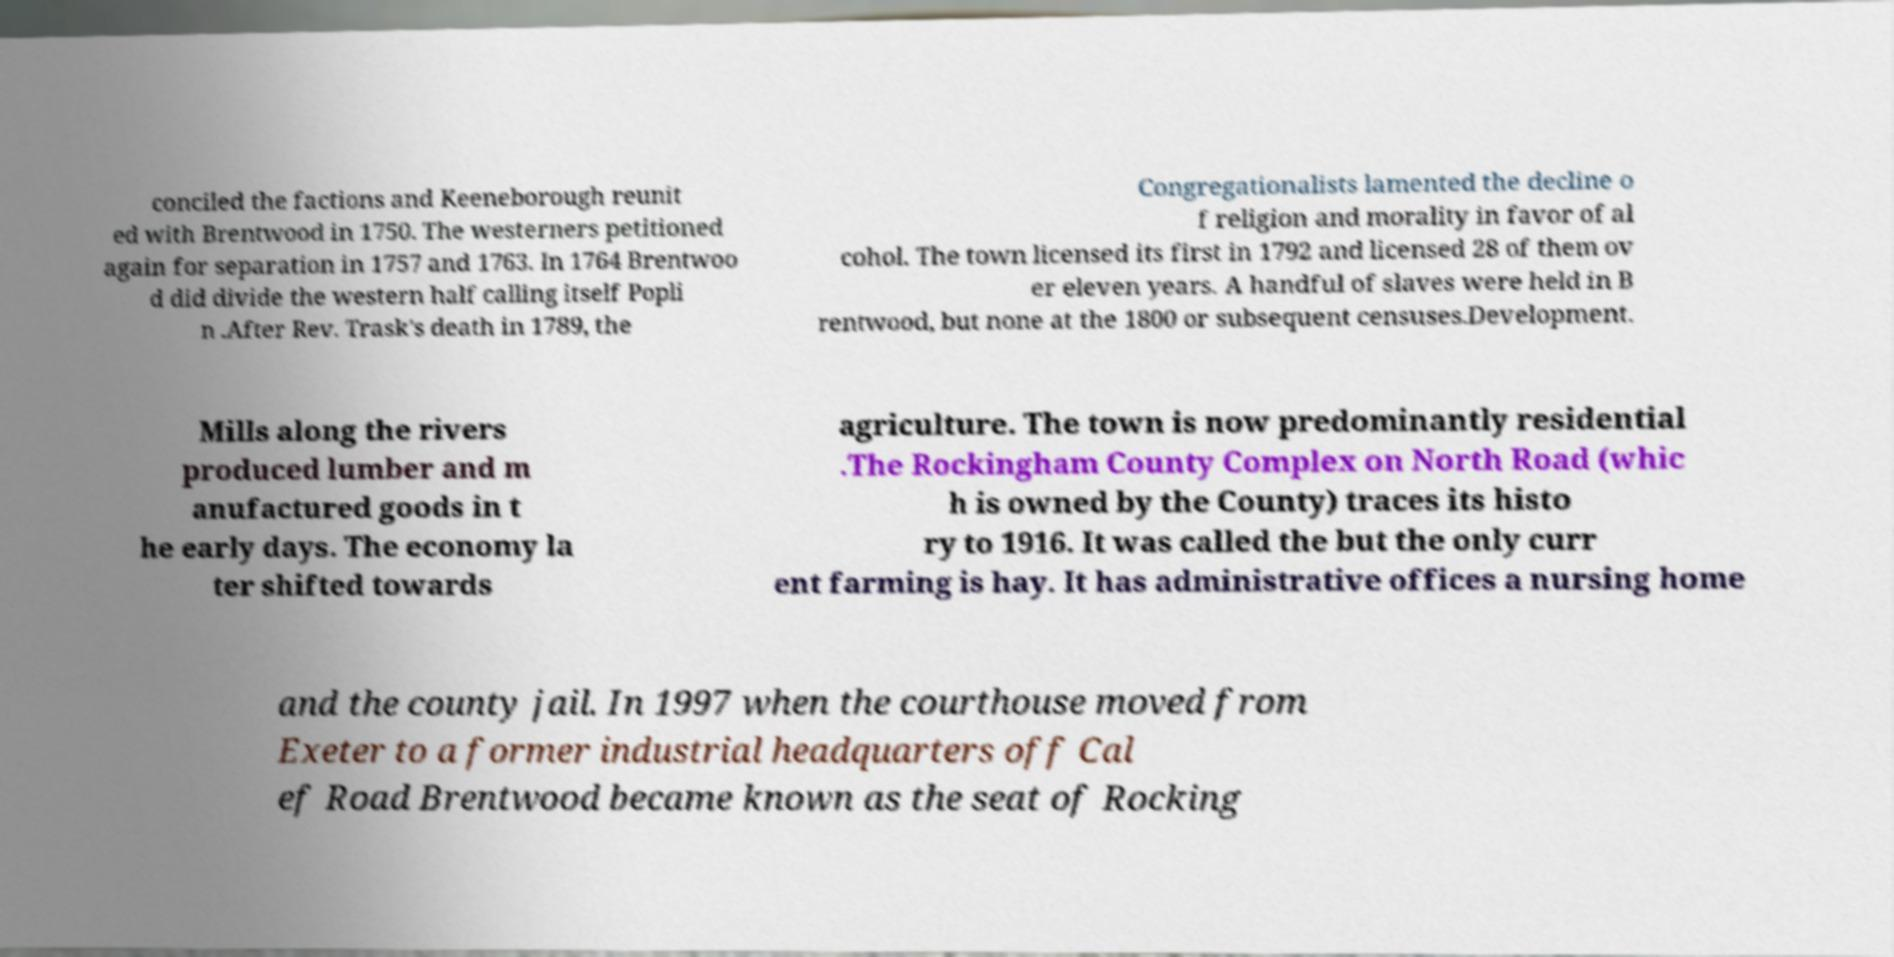Can you read and provide the text displayed in the image?This photo seems to have some interesting text. Can you extract and type it out for me? conciled the factions and Keeneborough reunit ed with Brentwood in 1750. The westerners petitioned again for separation in 1757 and 1763. In 1764 Brentwoo d did divide the western half calling itself Popli n .After Rev. Trask's death in 1789, the Congregationalists lamented the decline o f religion and morality in favor of al cohol. The town licensed its first in 1792 and licensed 28 of them ov er eleven years. A handful of slaves were held in B rentwood, but none at the 1800 or subsequent censuses.Development. Mills along the rivers produced lumber and m anufactured goods in t he early days. The economy la ter shifted towards agriculture. The town is now predominantly residential .The Rockingham County Complex on North Road (whic h is owned by the County) traces its histo ry to 1916. It was called the but the only curr ent farming is hay. It has administrative offices a nursing home and the county jail. In 1997 when the courthouse moved from Exeter to a former industrial headquarters off Cal ef Road Brentwood became known as the seat of Rocking 